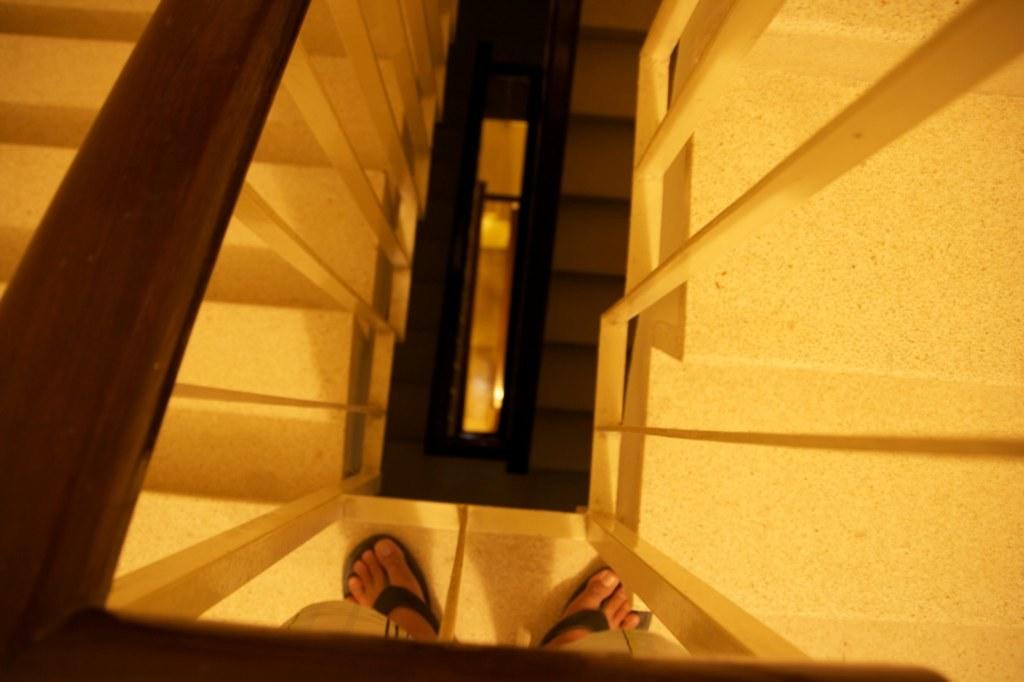What part of a person can be seen in the image? There are legs of a person visible in the image. What is present to provide support or safety in the image? There is railing in the image. Where are the stairs located on the left side of the image? The stairs are on the left side of the image. Are there stairs on both sides of the image? Yes, there are stairs on the right side of the image as well. What can be seen in the background of the image? There is railing and stairs visible in the background of the image. What type of flame can be seen on the scarecrow in the image? There is no scarecrow or flame present in the image. How is the knot tied in the image? There is no knot present in the image. 